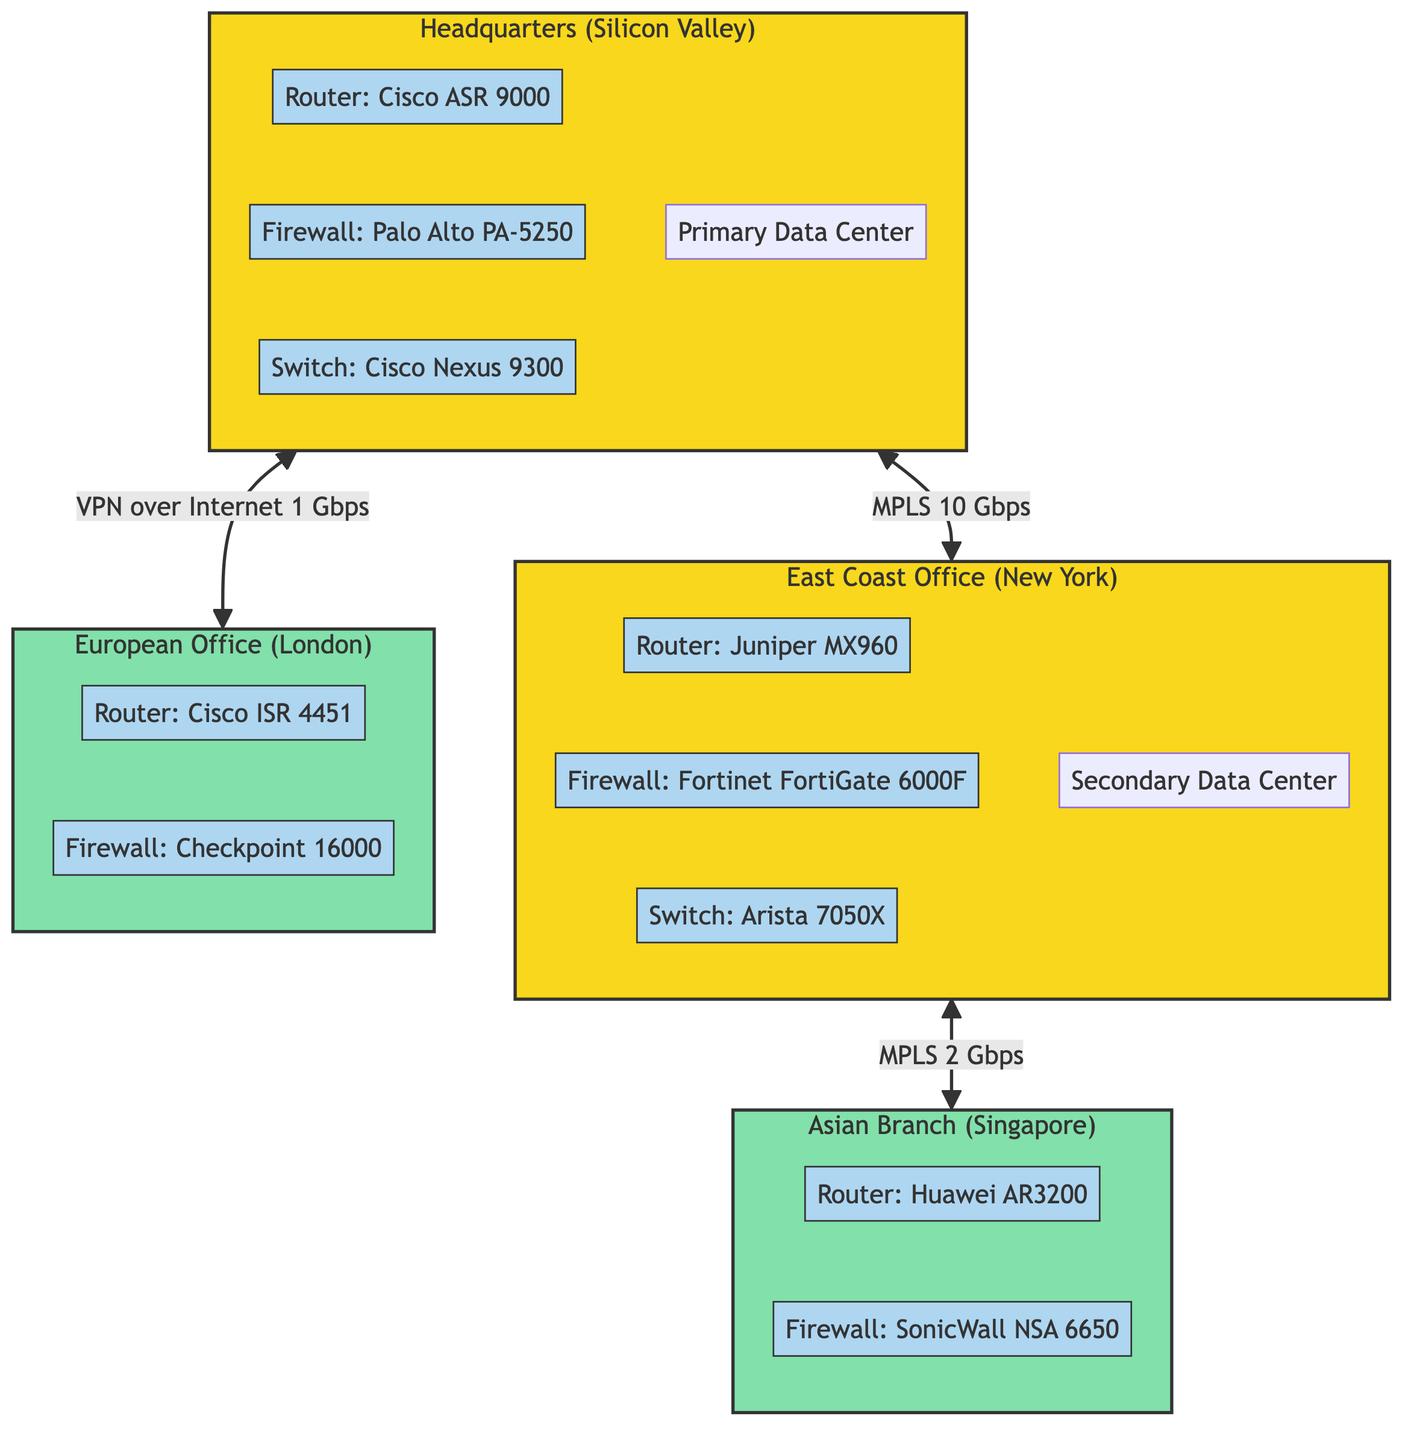What is the link type between Headquarters and East Coast Office? The diagram shows a communication link between Headquarters and East Coast Office labeled as "MPLS", indicating the type of connection used for data transfer.
Answer: MPLS How many offices are represented in the diagram? By examining the diagram, we can count the nodes representing offices: Headquarters, East Coast Office, European Office, and Asian Branch, totaling four offices.
Answer: 4 Which router model is used in the Headquarters? By looking at the section for Headquarters in the diagram, the router model displayed is "Cisco ASR 9000", which specifies the brand and model of the router used in that node.
Answer: Cisco ASR 9000 What is the bandwidth of the communication link from Headquarters to European Office? The diagram indicates a VPN over Internet connection from Headquarters to the European Office with a bandwidth labeled as "1 Gbps", giving the specific capacity of the link.
Answer: 1 Gbps Which firewall is used in the East Coast Office? The East Coast Office section in the diagram shows the firewall model as "Fortinet FortiGate 6000F", providing information on the network security device utilized there.
Answer: Fortinet FortiGate 6000F What type of communication link connects East Coast Office and Asian Branch? The connection between East Coast Office and Asian Branch is identified in the diagram as "MPLS", indicating that this is the method of communication between these two nodes.
Answer: MPLS How many network devices are present in the European Office? In the European Office subgraph, there are two network devices displayed: the router and the firewall, which gives us the total number of network devices in that particular node.
Answer: 2 Which main office has the primary data center? The diagram indicates that the Headquarters has a "Primary Data Center" associated with it, distinguishing it from other offices that might have different types of data centers.
Answer: Headquarters What is the type of link from Headquarters to East Coast Office? The diagram clearly shows the connection type between Headquarters and East Coast Office is labeled as "MPLS", which signifies the type of communication being used for this link.
Answer: MPLS 